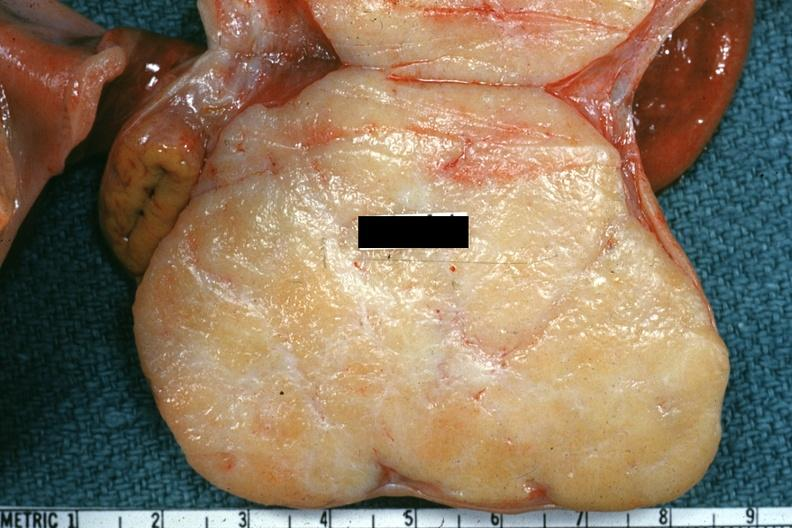what is present?
Answer the question using a single word or phrase. Ovary 